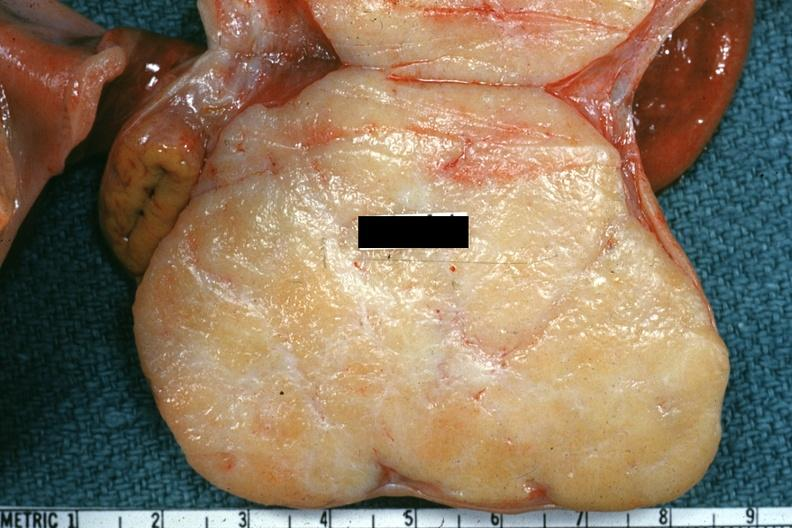what is present?
Answer the question using a single word or phrase. Ovary 